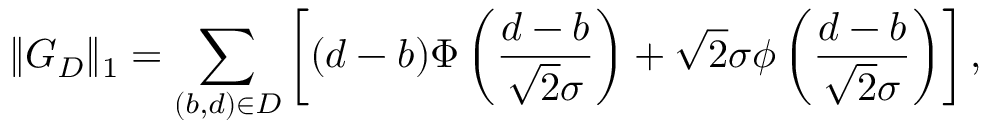<formula> <loc_0><loc_0><loc_500><loc_500>\| G _ { D } \| _ { 1 } = \sum _ { ( b , d ) \in D } \left [ ( d - b ) \Phi \left ( \frac { d - b } { \sqrt { 2 } \sigma } \right ) + \sqrt { 2 } \sigma \phi \left ( \frac { d - b } { \sqrt { 2 } \sigma } \right ) \right ] ,</formula> 